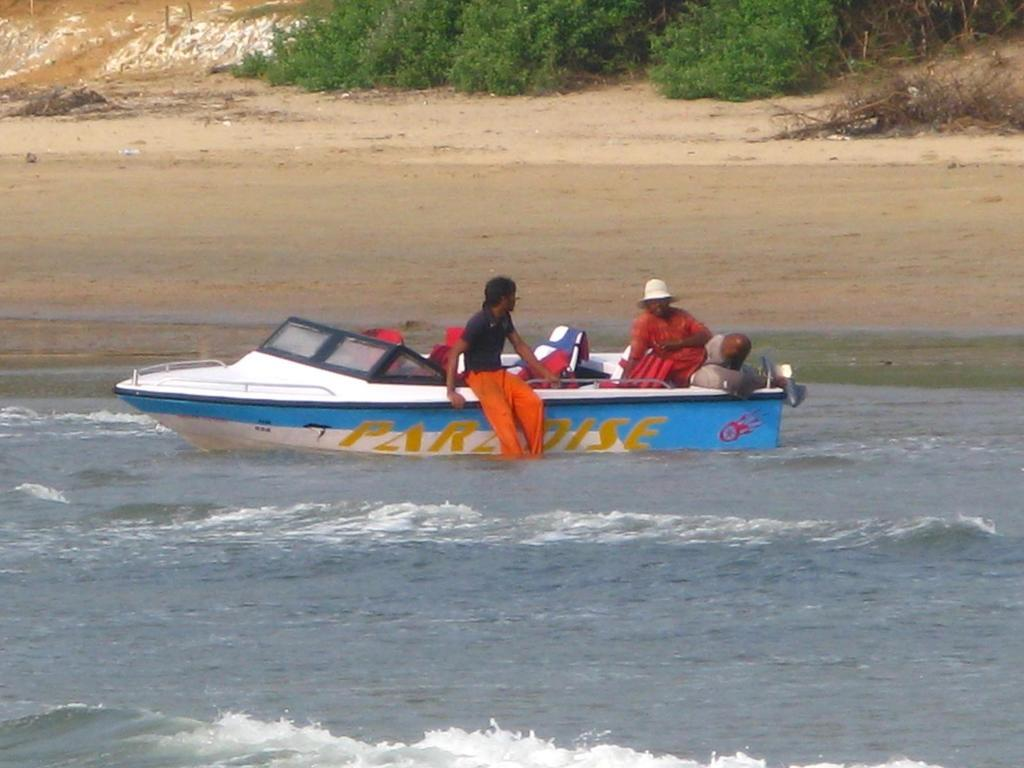What type of location is depicted at the bottom of the image? There is a beach at the bottom of the image. What can be seen on the beach? There is a boat on the beach. Who or what is in the boat? There are persons in the boat. What type of terrain is visible in the background of the image? There is sand and trees visible in the background of the image. What shape is the vest worn by the persons in the boat? There is no mention of a vest in the image, so we cannot determine its shape. 